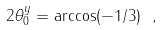<formula> <loc_0><loc_0><loc_500><loc_500>2 \theta _ { 0 } ^ { y } = \arccos ( - 1 / 3 ) \ ,</formula> 